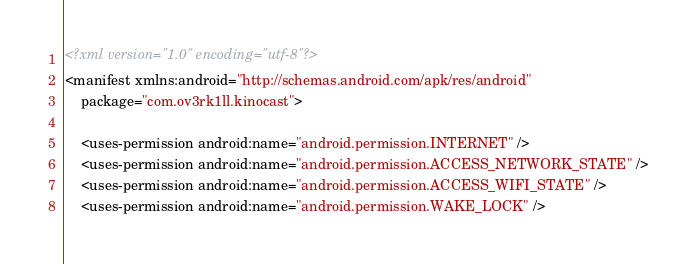<code> <loc_0><loc_0><loc_500><loc_500><_XML_><?xml version="1.0" encoding="utf-8"?>
<manifest xmlns:android="http://schemas.android.com/apk/res/android"
    package="com.ov3rk1ll.kinocast">

    <uses-permission android:name="android.permission.INTERNET" />
    <uses-permission android:name="android.permission.ACCESS_NETWORK_STATE" />
    <uses-permission android:name="android.permission.ACCESS_WIFI_STATE" />
    <uses-permission android:name="android.permission.WAKE_LOCK" /></code> 